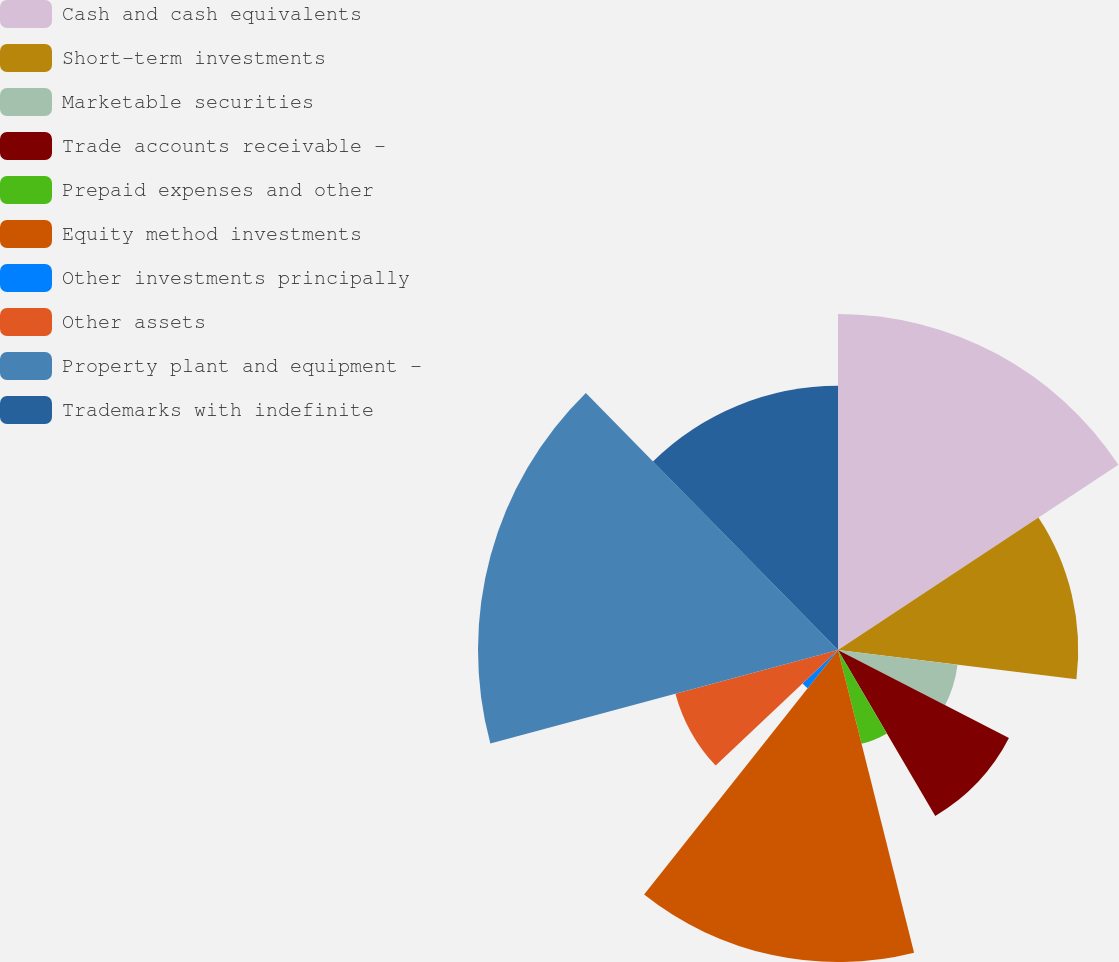<chart> <loc_0><loc_0><loc_500><loc_500><pie_chart><fcel>Cash and cash equivalents<fcel>Short-term investments<fcel>Marketable securities<fcel>Trade accounts receivable -<fcel>Prepaid expenses and other<fcel>Equity method investments<fcel>Other investments principally<fcel>Other assets<fcel>Property plant and equipment -<fcel>Trademarks with indefinite<nl><fcel>15.71%<fcel>11.23%<fcel>5.63%<fcel>8.99%<fcel>4.52%<fcel>14.59%<fcel>2.28%<fcel>7.87%<fcel>16.83%<fcel>12.35%<nl></chart> 